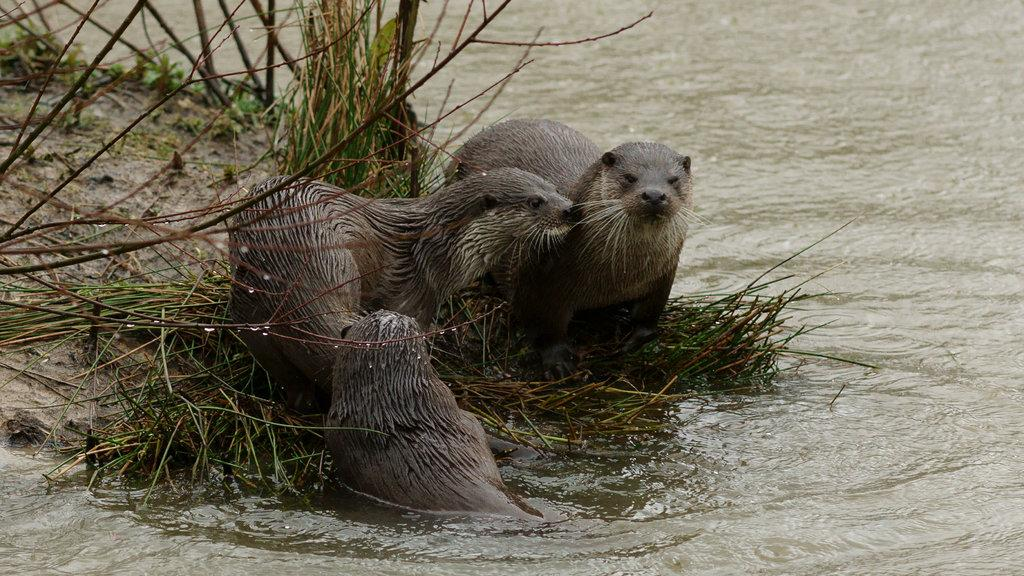What type of animals can be seen in the image? There are seals in the image. What other elements are present in the image besides the seals? There are plants and water visible in the image. Can you describe the interaction between the seals and the water? Yes, a seal is in the water in the image. What type of art is displayed on the passenger's shirt in the image? There is no passenger or shirt present in the image; it features seals, plants, and water. 